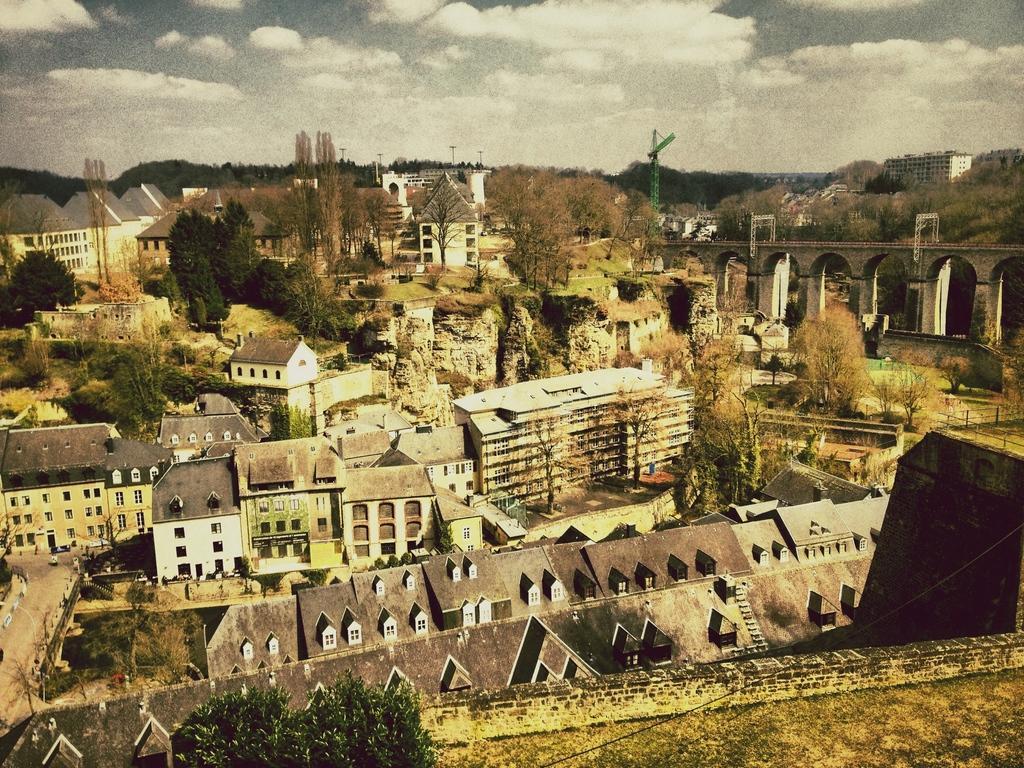Describe this image in one or two sentences. In this picture we can see few buildings, trees poles and a crane, and also we can see a bridge. 